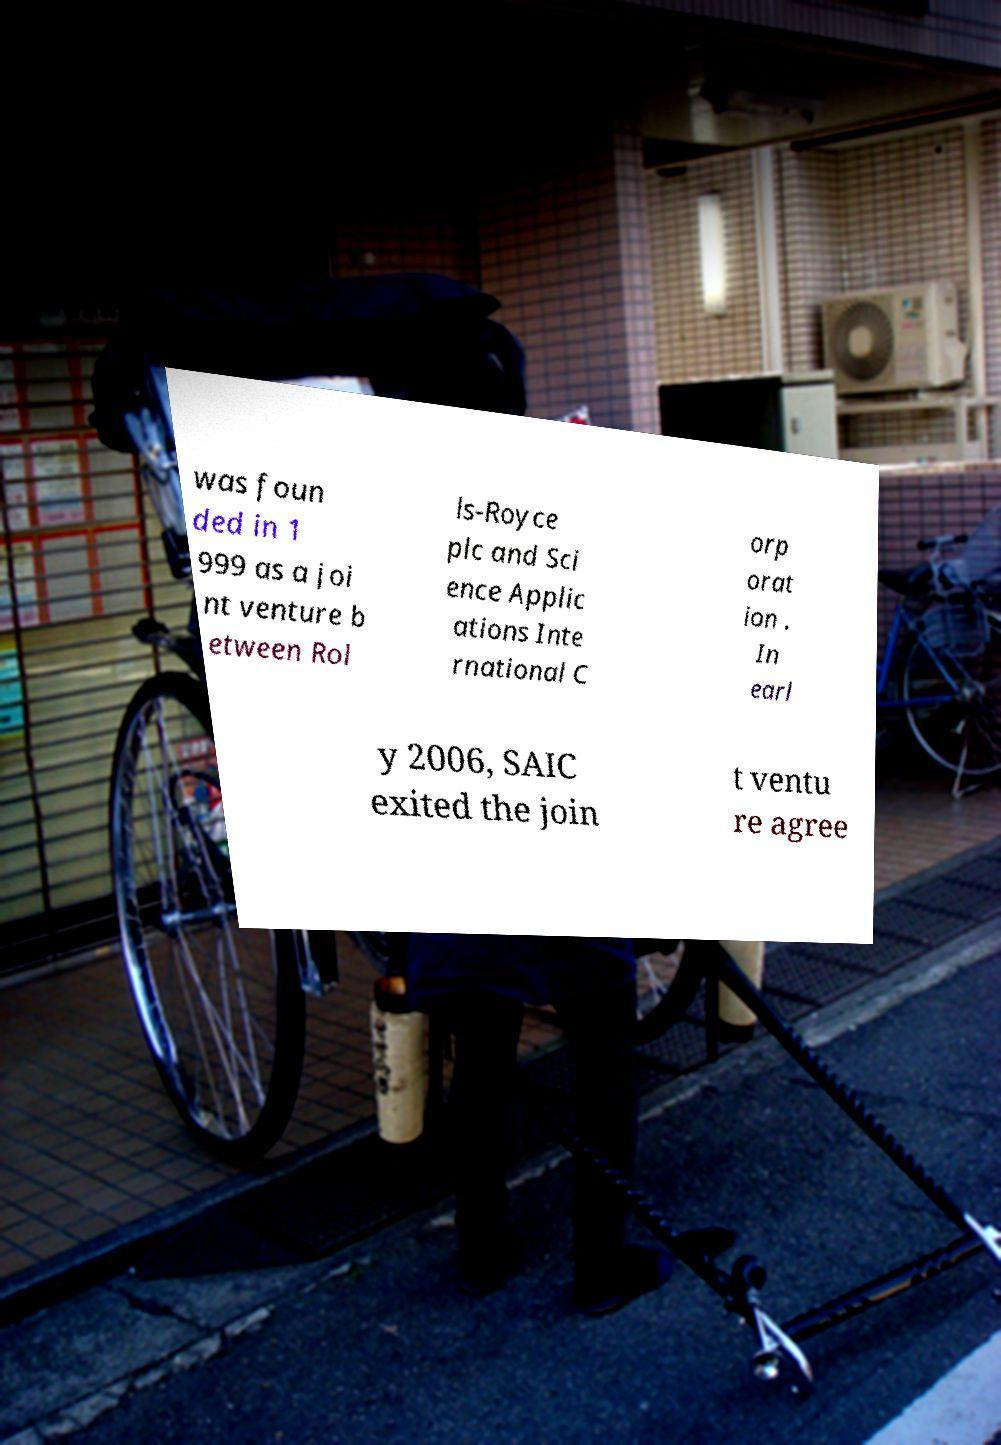Can you accurately transcribe the text from the provided image for me? was foun ded in 1 999 as a joi nt venture b etween Rol ls-Royce plc and Sci ence Applic ations Inte rnational C orp orat ion . In earl y 2006, SAIC exited the join t ventu re agree 